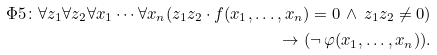Convert formula to latex. <formula><loc_0><loc_0><loc_500><loc_500>\Phi 5 \colon \forall z _ { 1 } \forall z _ { 2 } \forall x _ { 1 } \cdots \forall x _ { n } ( z _ { 1 } z _ { 2 } \cdot f ( x _ { 1 } , \dots , x _ { n } ) = 0 \, \wedge \, z _ { 1 } z _ { 2 } \ne 0 ) \\ \rightarrow ( \neg \, \varphi ( x _ { 1 } , \dots , x _ { n } ) ) .</formula> 